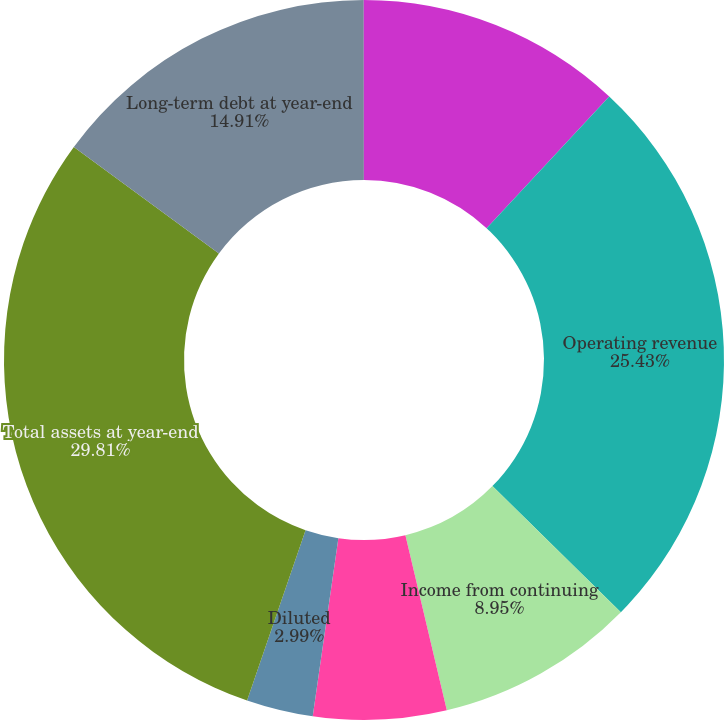Convert chart. <chart><loc_0><loc_0><loc_500><loc_500><pie_chart><fcel>In millions except per share<fcel>Operating revenue<fcel>Income from continuing<fcel>Basic<fcel>Diluted<fcel>Total assets at year-end<fcel>Long-term debt at year-end<fcel>Cash dividends declared per<nl><fcel>11.93%<fcel>25.43%<fcel>8.95%<fcel>5.97%<fcel>2.99%<fcel>29.82%<fcel>14.91%<fcel>0.01%<nl></chart> 